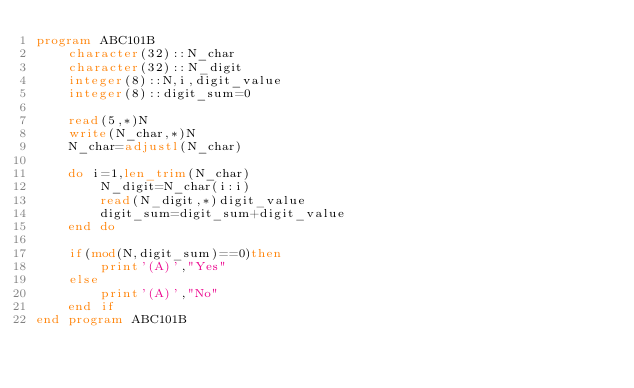Convert code to text. <code><loc_0><loc_0><loc_500><loc_500><_FORTRAN_>program ABC101B
	character(32)::N_char
	character(32)::N_digit
	integer(8)::N,i,digit_value
	integer(8)::digit_sum=0
	
	read(5,*)N
	write(N_char,*)N
	N_char=adjustl(N_char)
	
	do i=1,len_trim(N_char)
		N_digit=N_char(i:i)
		read(N_digit,*)digit_value
		digit_sum=digit_sum+digit_value
	end do
	
	if(mod(N,digit_sum)==0)then
		print'(A)',"Yes"
	else
		print'(A)',"No"
	end if
end program ABC101B
</code> 